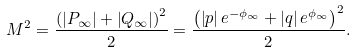<formula> <loc_0><loc_0><loc_500><loc_500>M ^ { 2 } = \frac { \left ( \left | P _ { \infty } \right | + \left | Q _ { \infty } \right | \right ) ^ { 2 } } { 2 } = \frac { \left ( \left | p \right | e ^ { - \phi _ { \infty } } + \left | q \right | e ^ { \phi _ { \infty } } \right ) ^ { 2 } } { 2 } .</formula> 